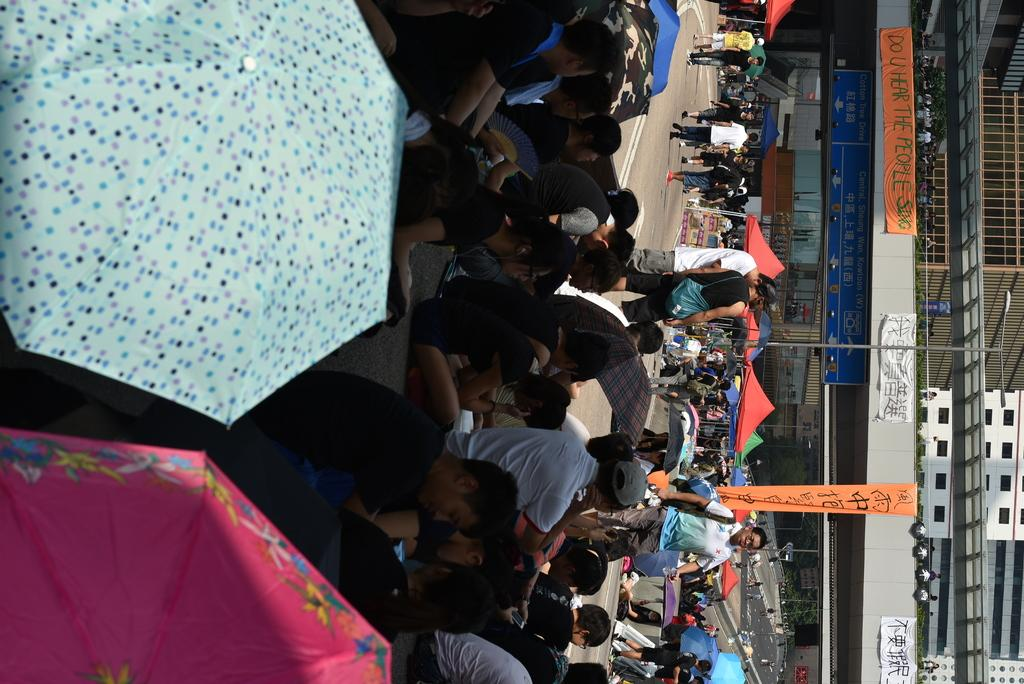What are the people in the image doing? There is a group of people sitting and a group of people standing in the image. What are the people holding in the image? The people are holding umbrellas in the image. What else can be seen in the image besides the people? Banners, buildings, a name board, plants, and stalls are visible in the image. Can you see any experts using rifles in the image? There are no experts or rifles present in the image. What is the end result of the event depicted in the image? The image does not depict an event with a specific end result; it simply shows a scene with people, umbrellas, banners, buildings, a name board, plants, and stalls. 